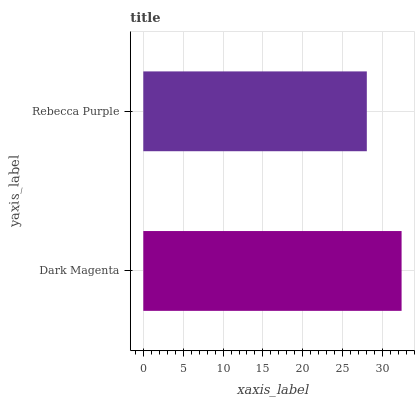Is Rebecca Purple the minimum?
Answer yes or no. Yes. Is Dark Magenta the maximum?
Answer yes or no. Yes. Is Rebecca Purple the maximum?
Answer yes or no. No. Is Dark Magenta greater than Rebecca Purple?
Answer yes or no. Yes. Is Rebecca Purple less than Dark Magenta?
Answer yes or no. Yes. Is Rebecca Purple greater than Dark Magenta?
Answer yes or no. No. Is Dark Magenta less than Rebecca Purple?
Answer yes or no. No. Is Dark Magenta the high median?
Answer yes or no. Yes. Is Rebecca Purple the low median?
Answer yes or no. Yes. Is Rebecca Purple the high median?
Answer yes or no. No. Is Dark Magenta the low median?
Answer yes or no. No. 